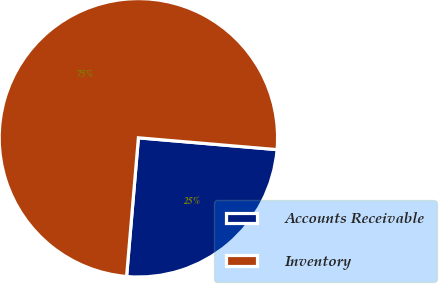<chart> <loc_0><loc_0><loc_500><loc_500><pie_chart><fcel>Accounts Receivable<fcel>Inventory<nl><fcel>25.0%<fcel>75.0%<nl></chart> 